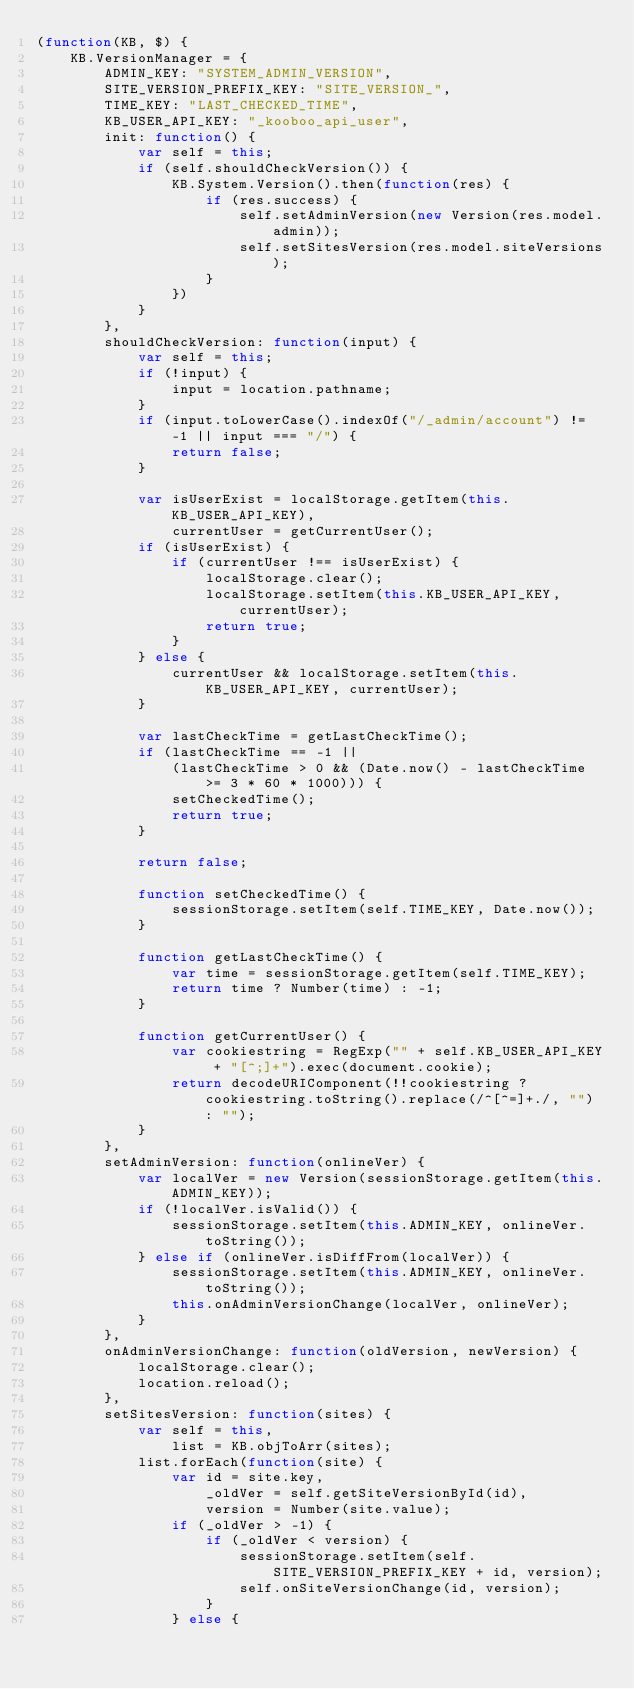<code> <loc_0><loc_0><loc_500><loc_500><_JavaScript_>(function(KB, $) {
    KB.VersionManager = {
        ADMIN_KEY: "SYSTEM_ADMIN_VERSION",
        SITE_VERSION_PREFIX_KEY: "SITE_VERSION_",
        TIME_KEY: "LAST_CHECKED_TIME",
        KB_USER_API_KEY: "_kooboo_api_user",
        init: function() {
            var self = this;
            if (self.shouldCheckVersion()) {
                KB.System.Version().then(function(res) {
                    if (res.success) {
                        self.setAdminVersion(new Version(res.model.admin));
                        self.setSitesVersion(res.model.siteVersions);
                    }
                })
            }
        },
        shouldCheckVersion: function(input) {
            var self = this;
            if (!input) {
                input = location.pathname;
            }
            if (input.toLowerCase().indexOf("/_admin/account") != -1 || input === "/") {
                return false;
            }

            var isUserExist = localStorage.getItem(this.KB_USER_API_KEY),
                currentUser = getCurrentUser();
            if (isUserExist) {
                if (currentUser !== isUserExist) {
                    localStorage.clear();
                    localStorage.setItem(this.KB_USER_API_KEY, currentUser);
                    return true;
                }
            } else {
                currentUser && localStorage.setItem(this.KB_USER_API_KEY, currentUser);
            }

            var lastCheckTime = getLastCheckTime();
            if (lastCheckTime == -1 ||
                (lastCheckTime > 0 && (Date.now() - lastCheckTime >= 3 * 60 * 1000))) {
                setCheckedTime();
                return true;
            }

            return false;

            function setCheckedTime() {
                sessionStorage.setItem(self.TIME_KEY, Date.now());
            }

            function getLastCheckTime() {
                var time = sessionStorage.getItem(self.TIME_KEY);
                return time ? Number(time) : -1;
            }

            function getCurrentUser() {
                var cookiestring = RegExp("" + self.KB_USER_API_KEY + "[^;]+").exec(document.cookie);
                return decodeURIComponent(!!cookiestring ? cookiestring.toString().replace(/^[^=]+./, "") : "");
            }
        },
        setAdminVersion: function(onlineVer) {
            var localVer = new Version(sessionStorage.getItem(this.ADMIN_KEY)); 
            if (!localVer.isValid()) {
                sessionStorage.setItem(this.ADMIN_KEY, onlineVer.toString());
            } else if (onlineVer.isDiffFrom(localVer)) {
                sessionStorage.setItem(this.ADMIN_KEY, onlineVer.toString());
                this.onAdminVersionChange(localVer, onlineVer);
            }
        },
        onAdminVersionChange: function(oldVersion, newVersion) {
            localStorage.clear();
            location.reload();
        },
        setSitesVersion: function(sites) {
            var self = this,
                list = KB.objToArr(sites);
            list.forEach(function(site) {
                var id = site.key,
                    _oldVer = self.getSiteVersionById(id),
                    version = Number(site.value);
                if (_oldVer > -1) {
                    if (_oldVer < version) {
                        sessionStorage.setItem(self.SITE_VERSION_PREFIX_KEY + id, version);
                        self.onSiteVersionChange(id, version);
                    }
                } else {</code> 